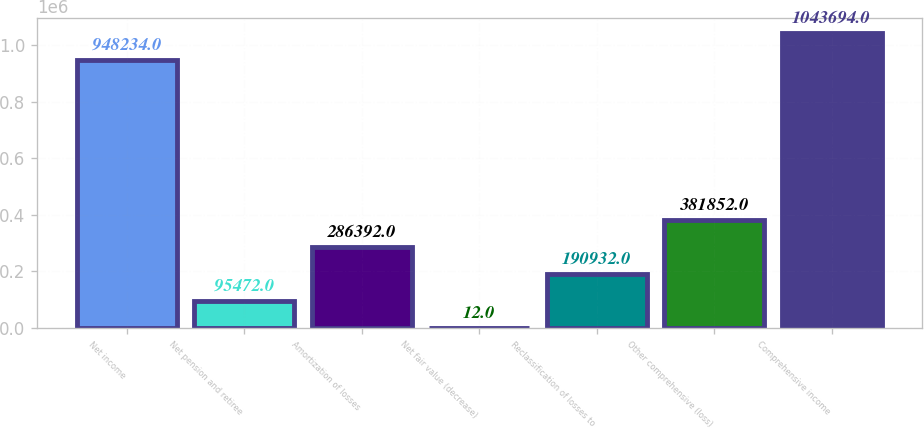Convert chart. <chart><loc_0><loc_0><loc_500><loc_500><bar_chart><fcel>Net income<fcel>Net pension and retiree<fcel>Amortization of losses<fcel>Net fair value (decrease)<fcel>Reclassification of losses to<fcel>Other comprehensive (loss)<fcel>Comprehensive income<nl><fcel>948234<fcel>95472<fcel>286392<fcel>12<fcel>190932<fcel>381852<fcel>1.04369e+06<nl></chart> 